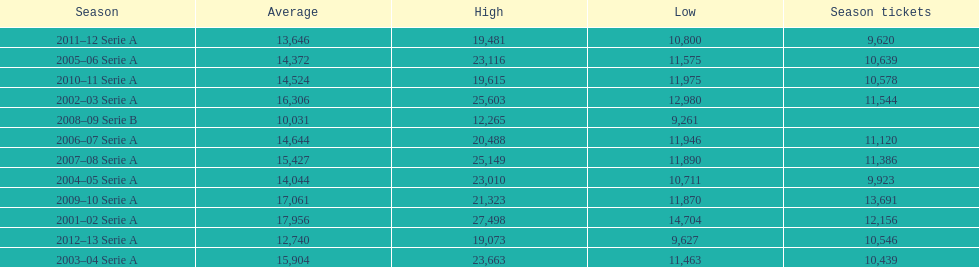How many seasons at the stadio ennio tardini had 11,000 or more season tickets? 5. 